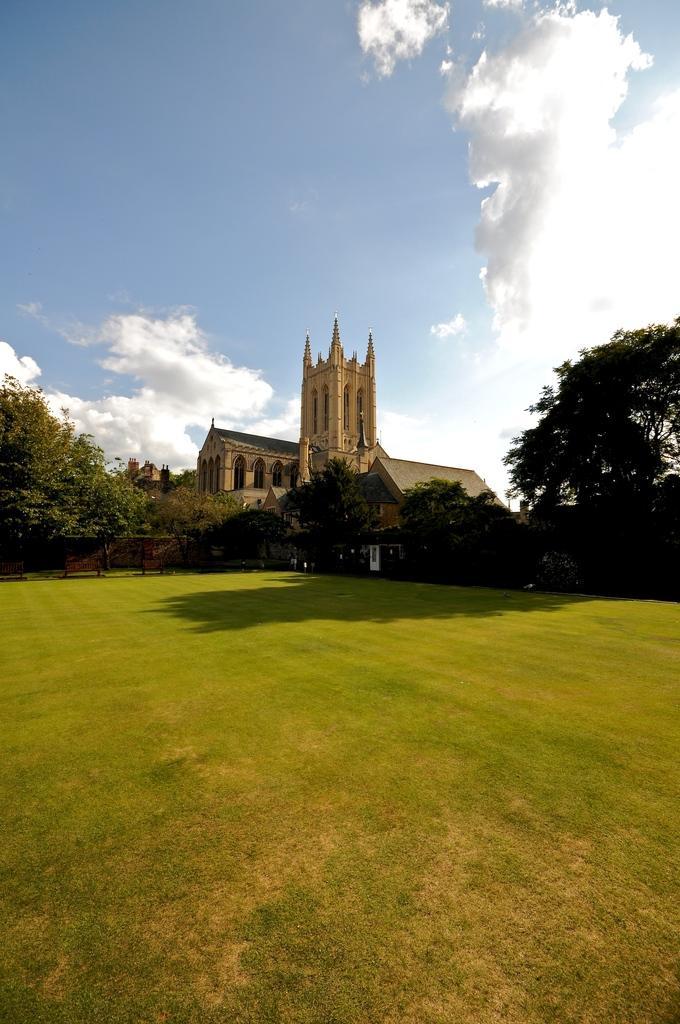How would you summarize this image in a sentence or two? In the center of the image we can see the sky, clouds, trees, grass, one building and fence. 